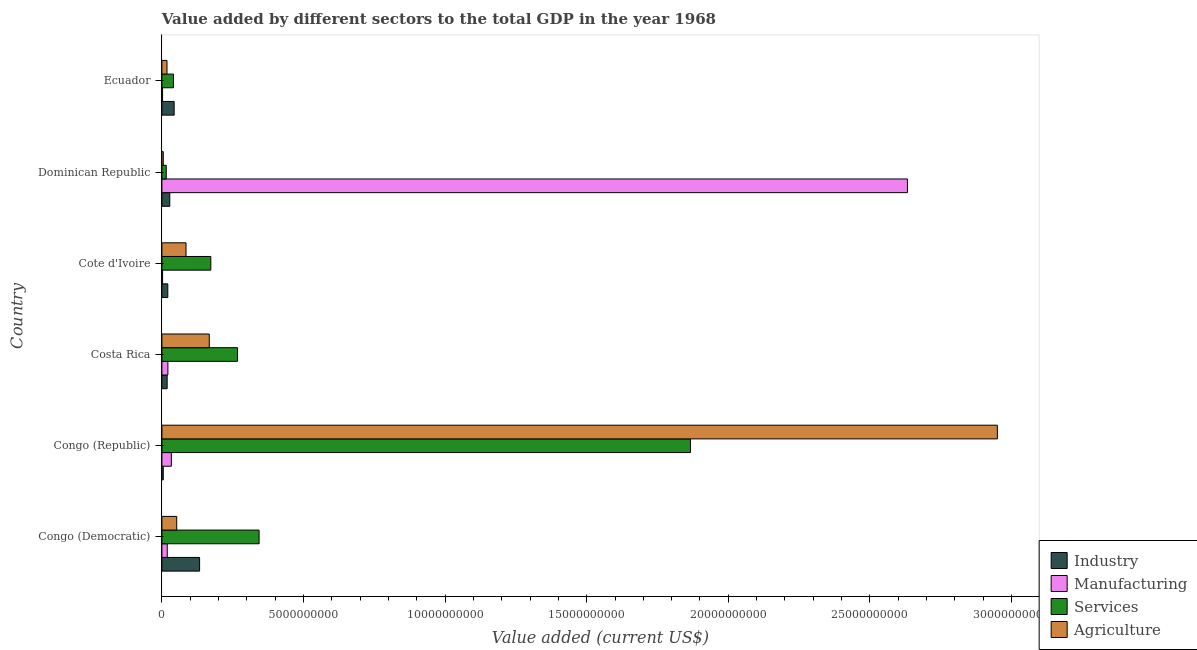How many groups of bars are there?
Ensure brevity in your answer.  6. How many bars are there on the 2nd tick from the bottom?
Ensure brevity in your answer.  4. What is the label of the 1st group of bars from the top?
Provide a succinct answer. Ecuador. In how many cases, is the number of bars for a given country not equal to the number of legend labels?
Ensure brevity in your answer.  0. What is the value added by industrial sector in Ecuador?
Offer a very short reply. 4.33e+08. Across all countries, what is the maximum value added by agricultural sector?
Your response must be concise. 2.95e+1. Across all countries, what is the minimum value added by manufacturing sector?
Your response must be concise. 2.34e+07. In which country was the value added by services sector maximum?
Keep it short and to the point. Congo (Republic). In which country was the value added by industrial sector minimum?
Keep it short and to the point. Congo (Republic). What is the total value added by services sector in the graph?
Your response must be concise. 2.71e+1. What is the difference between the value added by manufacturing sector in Congo (Democratic) and that in Congo (Republic)?
Make the answer very short. -1.45e+08. What is the difference between the value added by services sector in Ecuador and the value added by agricultural sector in Congo (Democratic)?
Offer a very short reply. -1.15e+08. What is the average value added by services sector per country?
Offer a terse response. 4.51e+09. What is the difference between the value added by services sector and value added by manufacturing sector in Cote d'Ivoire?
Ensure brevity in your answer.  1.70e+09. In how many countries, is the value added by industrial sector greater than 8000000000 US$?
Provide a succinct answer. 0. What is the ratio of the value added by services sector in Congo (Republic) to that in Ecuador?
Offer a very short reply. 45.74. Is the value added by industrial sector in Congo (Democratic) less than that in Costa Rica?
Provide a succinct answer. No. Is the difference between the value added by industrial sector in Congo (Democratic) and Cote d'Ivoire greater than the difference between the value added by agricultural sector in Congo (Democratic) and Cote d'Ivoire?
Ensure brevity in your answer.  Yes. What is the difference between the highest and the second highest value added by agricultural sector?
Ensure brevity in your answer.  2.78e+1. What is the difference between the highest and the lowest value added by services sector?
Keep it short and to the point. 1.85e+1. What does the 3rd bar from the top in Costa Rica represents?
Keep it short and to the point. Manufacturing. What does the 3rd bar from the bottom in Cote d'Ivoire represents?
Ensure brevity in your answer.  Services. Are all the bars in the graph horizontal?
Keep it short and to the point. Yes. How many countries are there in the graph?
Offer a terse response. 6. Are the values on the major ticks of X-axis written in scientific E-notation?
Ensure brevity in your answer.  No. Does the graph contain any zero values?
Offer a very short reply. No. Does the graph contain grids?
Your answer should be compact. No. Where does the legend appear in the graph?
Provide a succinct answer. Bottom right. How many legend labels are there?
Your response must be concise. 4. What is the title of the graph?
Make the answer very short. Value added by different sectors to the total GDP in the year 1968. Does "CO2 damage" appear as one of the legend labels in the graph?
Ensure brevity in your answer.  No. What is the label or title of the X-axis?
Provide a succinct answer. Value added (current US$). What is the Value added (current US$) in Industry in Congo (Democratic)?
Offer a very short reply. 1.33e+09. What is the Value added (current US$) of Manufacturing in Congo (Democratic)?
Provide a short and direct response. 1.89e+08. What is the Value added (current US$) of Services in Congo (Democratic)?
Make the answer very short. 3.43e+09. What is the Value added (current US$) in Agriculture in Congo (Democratic)?
Ensure brevity in your answer.  5.24e+08. What is the Value added (current US$) in Industry in Congo (Republic)?
Provide a succinct answer. 4.85e+07. What is the Value added (current US$) in Manufacturing in Congo (Republic)?
Your answer should be very brief. 3.34e+08. What is the Value added (current US$) of Services in Congo (Republic)?
Your answer should be compact. 1.87e+1. What is the Value added (current US$) in Agriculture in Congo (Republic)?
Your answer should be very brief. 2.95e+1. What is the Value added (current US$) of Industry in Costa Rica?
Ensure brevity in your answer.  1.86e+08. What is the Value added (current US$) in Manufacturing in Costa Rica?
Your answer should be compact. 2.11e+08. What is the Value added (current US$) of Services in Costa Rica?
Your answer should be compact. 2.67e+09. What is the Value added (current US$) of Agriculture in Costa Rica?
Make the answer very short. 1.67e+09. What is the Value added (current US$) of Industry in Cote d'Ivoire?
Make the answer very short. 2.09e+08. What is the Value added (current US$) of Manufacturing in Cote d'Ivoire?
Ensure brevity in your answer.  2.43e+07. What is the Value added (current US$) of Services in Cote d'Ivoire?
Provide a succinct answer. 1.73e+09. What is the Value added (current US$) in Agriculture in Cote d'Ivoire?
Offer a terse response. 8.52e+08. What is the Value added (current US$) of Industry in Dominican Republic?
Offer a terse response. 2.78e+08. What is the Value added (current US$) in Manufacturing in Dominican Republic?
Keep it short and to the point. 2.63e+1. What is the Value added (current US$) of Services in Dominican Republic?
Your answer should be compact. 1.53e+08. What is the Value added (current US$) in Agriculture in Dominican Republic?
Offer a terse response. 4.93e+07. What is the Value added (current US$) in Industry in Ecuador?
Keep it short and to the point. 4.33e+08. What is the Value added (current US$) of Manufacturing in Ecuador?
Your answer should be compact. 2.34e+07. What is the Value added (current US$) in Services in Ecuador?
Provide a short and direct response. 4.08e+08. What is the Value added (current US$) in Agriculture in Ecuador?
Give a very brief answer. 1.80e+08. Across all countries, what is the maximum Value added (current US$) of Industry?
Provide a succinct answer. 1.33e+09. Across all countries, what is the maximum Value added (current US$) in Manufacturing?
Provide a succinct answer. 2.63e+1. Across all countries, what is the maximum Value added (current US$) of Services?
Your response must be concise. 1.87e+1. Across all countries, what is the maximum Value added (current US$) of Agriculture?
Your response must be concise. 2.95e+1. Across all countries, what is the minimum Value added (current US$) of Industry?
Offer a very short reply. 4.85e+07. Across all countries, what is the minimum Value added (current US$) of Manufacturing?
Offer a terse response. 2.34e+07. Across all countries, what is the minimum Value added (current US$) in Services?
Your response must be concise. 1.53e+08. Across all countries, what is the minimum Value added (current US$) in Agriculture?
Give a very brief answer. 4.93e+07. What is the total Value added (current US$) of Industry in the graph?
Your answer should be very brief. 2.48e+09. What is the total Value added (current US$) of Manufacturing in the graph?
Your response must be concise. 2.71e+1. What is the total Value added (current US$) in Services in the graph?
Offer a terse response. 2.71e+1. What is the total Value added (current US$) in Agriculture in the graph?
Your answer should be very brief. 3.28e+1. What is the difference between the Value added (current US$) in Industry in Congo (Democratic) and that in Congo (Republic)?
Your answer should be compact. 1.28e+09. What is the difference between the Value added (current US$) in Manufacturing in Congo (Democratic) and that in Congo (Republic)?
Offer a very short reply. -1.45e+08. What is the difference between the Value added (current US$) of Services in Congo (Democratic) and that in Congo (Republic)?
Provide a succinct answer. -1.52e+1. What is the difference between the Value added (current US$) in Agriculture in Congo (Democratic) and that in Congo (Republic)?
Provide a succinct answer. -2.90e+1. What is the difference between the Value added (current US$) of Industry in Congo (Democratic) and that in Costa Rica?
Your answer should be very brief. 1.15e+09. What is the difference between the Value added (current US$) of Manufacturing in Congo (Democratic) and that in Costa Rica?
Your answer should be compact. -2.24e+07. What is the difference between the Value added (current US$) of Services in Congo (Democratic) and that in Costa Rica?
Your answer should be compact. 7.61e+08. What is the difference between the Value added (current US$) in Agriculture in Congo (Democratic) and that in Costa Rica?
Ensure brevity in your answer.  -1.15e+09. What is the difference between the Value added (current US$) in Industry in Congo (Democratic) and that in Cote d'Ivoire?
Give a very brief answer. 1.12e+09. What is the difference between the Value added (current US$) of Manufacturing in Congo (Democratic) and that in Cote d'Ivoire?
Make the answer very short. 1.65e+08. What is the difference between the Value added (current US$) of Services in Congo (Democratic) and that in Cote d'Ivoire?
Provide a succinct answer. 1.70e+09. What is the difference between the Value added (current US$) of Agriculture in Congo (Democratic) and that in Cote d'Ivoire?
Offer a terse response. -3.28e+08. What is the difference between the Value added (current US$) of Industry in Congo (Democratic) and that in Dominican Republic?
Your answer should be very brief. 1.05e+09. What is the difference between the Value added (current US$) in Manufacturing in Congo (Democratic) and that in Dominican Republic?
Offer a very short reply. -2.61e+1. What is the difference between the Value added (current US$) of Services in Congo (Democratic) and that in Dominican Republic?
Provide a succinct answer. 3.28e+09. What is the difference between the Value added (current US$) of Agriculture in Congo (Democratic) and that in Dominican Republic?
Provide a short and direct response. 4.74e+08. What is the difference between the Value added (current US$) in Industry in Congo (Democratic) and that in Ecuador?
Provide a short and direct response. 8.98e+08. What is the difference between the Value added (current US$) of Manufacturing in Congo (Democratic) and that in Ecuador?
Make the answer very short. 1.66e+08. What is the difference between the Value added (current US$) of Services in Congo (Democratic) and that in Ecuador?
Your answer should be very brief. 3.02e+09. What is the difference between the Value added (current US$) of Agriculture in Congo (Democratic) and that in Ecuador?
Offer a terse response. 3.43e+08. What is the difference between the Value added (current US$) of Industry in Congo (Republic) and that in Costa Rica?
Offer a terse response. -1.37e+08. What is the difference between the Value added (current US$) of Manufacturing in Congo (Republic) and that in Costa Rica?
Make the answer very short. 1.22e+08. What is the difference between the Value added (current US$) of Services in Congo (Republic) and that in Costa Rica?
Your answer should be very brief. 1.60e+1. What is the difference between the Value added (current US$) of Agriculture in Congo (Republic) and that in Costa Rica?
Your answer should be compact. 2.78e+1. What is the difference between the Value added (current US$) in Industry in Congo (Republic) and that in Cote d'Ivoire?
Provide a short and direct response. -1.60e+08. What is the difference between the Value added (current US$) of Manufacturing in Congo (Republic) and that in Cote d'Ivoire?
Your answer should be compact. 3.09e+08. What is the difference between the Value added (current US$) of Services in Congo (Republic) and that in Cote d'Ivoire?
Provide a short and direct response. 1.69e+1. What is the difference between the Value added (current US$) of Agriculture in Congo (Republic) and that in Cote d'Ivoire?
Give a very brief answer. 2.87e+1. What is the difference between the Value added (current US$) in Industry in Congo (Republic) and that in Dominican Republic?
Keep it short and to the point. -2.30e+08. What is the difference between the Value added (current US$) of Manufacturing in Congo (Republic) and that in Dominican Republic?
Provide a short and direct response. -2.60e+1. What is the difference between the Value added (current US$) of Services in Congo (Republic) and that in Dominican Republic?
Offer a very short reply. 1.85e+1. What is the difference between the Value added (current US$) of Agriculture in Congo (Republic) and that in Dominican Republic?
Offer a very short reply. 2.95e+1. What is the difference between the Value added (current US$) of Industry in Congo (Republic) and that in Ecuador?
Offer a very short reply. -3.84e+08. What is the difference between the Value added (current US$) of Manufacturing in Congo (Republic) and that in Ecuador?
Your response must be concise. 3.10e+08. What is the difference between the Value added (current US$) in Services in Congo (Republic) and that in Ecuador?
Provide a succinct answer. 1.83e+1. What is the difference between the Value added (current US$) in Agriculture in Congo (Republic) and that in Ecuador?
Offer a very short reply. 2.93e+1. What is the difference between the Value added (current US$) in Industry in Costa Rica and that in Cote d'Ivoire?
Offer a very short reply. -2.32e+07. What is the difference between the Value added (current US$) in Manufacturing in Costa Rica and that in Cote d'Ivoire?
Ensure brevity in your answer.  1.87e+08. What is the difference between the Value added (current US$) of Services in Costa Rica and that in Cote d'Ivoire?
Your response must be concise. 9.44e+08. What is the difference between the Value added (current US$) of Agriculture in Costa Rica and that in Cote d'Ivoire?
Offer a terse response. 8.21e+08. What is the difference between the Value added (current US$) of Industry in Costa Rica and that in Dominican Republic?
Make the answer very short. -9.24e+07. What is the difference between the Value added (current US$) in Manufacturing in Costa Rica and that in Dominican Republic?
Provide a succinct answer. -2.61e+1. What is the difference between the Value added (current US$) in Services in Costa Rica and that in Dominican Republic?
Provide a succinct answer. 2.52e+09. What is the difference between the Value added (current US$) in Agriculture in Costa Rica and that in Dominican Republic?
Give a very brief answer. 1.62e+09. What is the difference between the Value added (current US$) of Industry in Costa Rica and that in Ecuador?
Ensure brevity in your answer.  -2.47e+08. What is the difference between the Value added (current US$) of Manufacturing in Costa Rica and that in Ecuador?
Offer a very short reply. 1.88e+08. What is the difference between the Value added (current US$) of Services in Costa Rica and that in Ecuador?
Your answer should be very brief. 2.26e+09. What is the difference between the Value added (current US$) of Agriculture in Costa Rica and that in Ecuador?
Keep it short and to the point. 1.49e+09. What is the difference between the Value added (current US$) in Industry in Cote d'Ivoire and that in Dominican Republic?
Keep it short and to the point. -6.92e+07. What is the difference between the Value added (current US$) in Manufacturing in Cote d'Ivoire and that in Dominican Republic?
Offer a very short reply. -2.63e+1. What is the difference between the Value added (current US$) of Services in Cote d'Ivoire and that in Dominican Republic?
Ensure brevity in your answer.  1.57e+09. What is the difference between the Value added (current US$) of Agriculture in Cote d'Ivoire and that in Dominican Republic?
Offer a very short reply. 8.02e+08. What is the difference between the Value added (current US$) of Industry in Cote d'Ivoire and that in Ecuador?
Keep it short and to the point. -2.24e+08. What is the difference between the Value added (current US$) of Manufacturing in Cote d'Ivoire and that in Ecuador?
Offer a terse response. 8.48e+05. What is the difference between the Value added (current US$) of Services in Cote d'Ivoire and that in Ecuador?
Keep it short and to the point. 1.32e+09. What is the difference between the Value added (current US$) of Agriculture in Cote d'Ivoire and that in Ecuador?
Offer a very short reply. 6.71e+08. What is the difference between the Value added (current US$) in Industry in Dominican Republic and that in Ecuador?
Your answer should be compact. -1.55e+08. What is the difference between the Value added (current US$) in Manufacturing in Dominican Republic and that in Ecuador?
Your response must be concise. 2.63e+1. What is the difference between the Value added (current US$) in Services in Dominican Republic and that in Ecuador?
Offer a terse response. -2.55e+08. What is the difference between the Value added (current US$) in Agriculture in Dominican Republic and that in Ecuador?
Offer a very short reply. -1.31e+08. What is the difference between the Value added (current US$) in Industry in Congo (Democratic) and the Value added (current US$) in Manufacturing in Congo (Republic)?
Keep it short and to the point. 9.97e+08. What is the difference between the Value added (current US$) of Industry in Congo (Democratic) and the Value added (current US$) of Services in Congo (Republic)?
Your answer should be compact. -1.73e+1. What is the difference between the Value added (current US$) in Industry in Congo (Democratic) and the Value added (current US$) in Agriculture in Congo (Republic)?
Your response must be concise. -2.82e+1. What is the difference between the Value added (current US$) in Manufacturing in Congo (Democratic) and the Value added (current US$) in Services in Congo (Republic)?
Make the answer very short. -1.85e+1. What is the difference between the Value added (current US$) in Manufacturing in Congo (Democratic) and the Value added (current US$) in Agriculture in Congo (Republic)?
Your answer should be very brief. -2.93e+1. What is the difference between the Value added (current US$) of Services in Congo (Democratic) and the Value added (current US$) of Agriculture in Congo (Republic)?
Your answer should be compact. -2.61e+1. What is the difference between the Value added (current US$) in Industry in Congo (Democratic) and the Value added (current US$) in Manufacturing in Costa Rica?
Make the answer very short. 1.12e+09. What is the difference between the Value added (current US$) of Industry in Congo (Democratic) and the Value added (current US$) of Services in Costa Rica?
Offer a terse response. -1.34e+09. What is the difference between the Value added (current US$) of Industry in Congo (Democratic) and the Value added (current US$) of Agriculture in Costa Rica?
Offer a terse response. -3.42e+08. What is the difference between the Value added (current US$) in Manufacturing in Congo (Democratic) and the Value added (current US$) in Services in Costa Rica?
Your answer should be very brief. -2.48e+09. What is the difference between the Value added (current US$) of Manufacturing in Congo (Democratic) and the Value added (current US$) of Agriculture in Costa Rica?
Give a very brief answer. -1.48e+09. What is the difference between the Value added (current US$) in Services in Congo (Democratic) and the Value added (current US$) in Agriculture in Costa Rica?
Provide a short and direct response. 1.76e+09. What is the difference between the Value added (current US$) of Industry in Congo (Democratic) and the Value added (current US$) of Manufacturing in Cote d'Ivoire?
Keep it short and to the point. 1.31e+09. What is the difference between the Value added (current US$) of Industry in Congo (Democratic) and the Value added (current US$) of Services in Cote d'Ivoire?
Offer a terse response. -3.96e+08. What is the difference between the Value added (current US$) in Industry in Congo (Democratic) and the Value added (current US$) in Agriculture in Cote d'Ivoire?
Keep it short and to the point. 4.79e+08. What is the difference between the Value added (current US$) in Manufacturing in Congo (Democratic) and the Value added (current US$) in Services in Cote d'Ivoire?
Your answer should be compact. -1.54e+09. What is the difference between the Value added (current US$) of Manufacturing in Congo (Democratic) and the Value added (current US$) of Agriculture in Cote d'Ivoire?
Offer a very short reply. -6.63e+08. What is the difference between the Value added (current US$) in Services in Congo (Democratic) and the Value added (current US$) in Agriculture in Cote d'Ivoire?
Make the answer very short. 2.58e+09. What is the difference between the Value added (current US$) of Industry in Congo (Democratic) and the Value added (current US$) of Manufacturing in Dominican Republic?
Provide a short and direct response. -2.50e+1. What is the difference between the Value added (current US$) of Industry in Congo (Democratic) and the Value added (current US$) of Services in Dominican Republic?
Offer a very short reply. 1.18e+09. What is the difference between the Value added (current US$) of Industry in Congo (Democratic) and the Value added (current US$) of Agriculture in Dominican Republic?
Ensure brevity in your answer.  1.28e+09. What is the difference between the Value added (current US$) of Manufacturing in Congo (Democratic) and the Value added (current US$) of Services in Dominican Republic?
Your response must be concise. 3.55e+07. What is the difference between the Value added (current US$) in Manufacturing in Congo (Democratic) and the Value added (current US$) in Agriculture in Dominican Republic?
Give a very brief answer. 1.40e+08. What is the difference between the Value added (current US$) of Services in Congo (Democratic) and the Value added (current US$) of Agriculture in Dominican Republic?
Provide a short and direct response. 3.38e+09. What is the difference between the Value added (current US$) in Industry in Congo (Democratic) and the Value added (current US$) in Manufacturing in Ecuador?
Keep it short and to the point. 1.31e+09. What is the difference between the Value added (current US$) of Industry in Congo (Democratic) and the Value added (current US$) of Services in Ecuador?
Provide a succinct answer. 9.23e+08. What is the difference between the Value added (current US$) of Industry in Congo (Democratic) and the Value added (current US$) of Agriculture in Ecuador?
Give a very brief answer. 1.15e+09. What is the difference between the Value added (current US$) in Manufacturing in Congo (Democratic) and the Value added (current US$) in Services in Ecuador?
Your response must be concise. -2.19e+08. What is the difference between the Value added (current US$) of Manufacturing in Congo (Democratic) and the Value added (current US$) of Agriculture in Ecuador?
Offer a very short reply. 8.86e+06. What is the difference between the Value added (current US$) of Services in Congo (Democratic) and the Value added (current US$) of Agriculture in Ecuador?
Provide a succinct answer. 3.25e+09. What is the difference between the Value added (current US$) in Industry in Congo (Republic) and the Value added (current US$) in Manufacturing in Costa Rica?
Make the answer very short. -1.63e+08. What is the difference between the Value added (current US$) of Industry in Congo (Republic) and the Value added (current US$) of Services in Costa Rica?
Provide a succinct answer. -2.62e+09. What is the difference between the Value added (current US$) of Industry in Congo (Republic) and the Value added (current US$) of Agriculture in Costa Rica?
Make the answer very short. -1.62e+09. What is the difference between the Value added (current US$) of Manufacturing in Congo (Republic) and the Value added (current US$) of Services in Costa Rica?
Your response must be concise. -2.34e+09. What is the difference between the Value added (current US$) in Manufacturing in Congo (Republic) and the Value added (current US$) in Agriculture in Costa Rica?
Ensure brevity in your answer.  -1.34e+09. What is the difference between the Value added (current US$) of Services in Congo (Republic) and the Value added (current US$) of Agriculture in Costa Rica?
Provide a short and direct response. 1.70e+1. What is the difference between the Value added (current US$) of Industry in Congo (Republic) and the Value added (current US$) of Manufacturing in Cote d'Ivoire?
Provide a succinct answer. 2.42e+07. What is the difference between the Value added (current US$) in Industry in Congo (Republic) and the Value added (current US$) in Services in Cote d'Ivoire?
Your response must be concise. -1.68e+09. What is the difference between the Value added (current US$) in Industry in Congo (Republic) and the Value added (current US$) in Agriculture in Cote d'Ivoire?
Give a very brief answer. -8.03e+08. What is the difference between the Value added (current US$) in Manufacturing in Congo (Republic) and the Value added (current US$) in Services in Cote d'Ivoire?
Offer a very short reply. -1.39e+09. What is the difference between the Value added (current US$) in Manufacturing in Congo (Republic) and the Value added (current US$) in Agriculture in Cote d'Ivoire?
Your response must be concise. -5.18e+08. What is the difference between the Value added (current US$) in Services in Congo (Republic) and the Value added (current US$) in Agriculture in Cote d'Ivoire?
Your answer should be compact. 1.78e+1. What is the difference between the Value added (current US$) of Industry in Congo (Republic) and the Value added (current US$) of Manufacturing in Dominican Republic?
Your response must be concise. -2.63e+1. What is the difference between the Value added (current US$) in Industry in Congo (Republic) and the Value added (current US$) in Services in Dominican Republic?
Ensure brevity in your answer.  -1.05e+08. What is the difference between the Value added (current US$) in Industry in Congo (Republic) and the Value added (current US$) in Agriculture in Dominican Republic?
Make the answer very short. -8.08e+05. What is the difference between the Value added (current US$) of Manufacturing in Congo (Republic) and the Value added (current US$) of Services in Dominican Republic?
Provide a succinct answer. 1.80e+08. What is the difference between the Value added (current US$) of Manufacturing in Congo (Republic) and the Value added (current US$) of Agriculture in Dominican Republic?
Your answer should be very brief. 2.84e+08. What is the difference between the Value added (current US$) in Services in Congo (Republic) and the Value added (current US$) in Agriculture in Dominican Republic?
Keep it short and to the point. 1.86e+1. What is the difference between the Value added (current US$) in Industry in Congo (Republic) and the Value added (current US$) in Manufacturing in Ecuador?
Ensure brevity in your answer.  2.50e+07. What is the difference between the Value added (current US$) of Industry in Congo (Republic) and the Value added (current US$) of Services in Ecuador?
Give a very brief answer. -3.60e+08. What is the difference between the Value added (current US$) of Industry in Congo (Republic) and the Value added (current US$) of Agriculture in Ecuador?
Your answer should be compact. -1.32e+08. What is the difference between the Value added (current US$) of Manufacturing in Congo (Republic) and the Value added (current US$) of Services in Ecuador?
Provide a short and direct response. -7.45e+07. What is the difference between the Value added (current US$) of Manufacturing in Congo (Republic) and the Value added (current US$) of Agriculture in Ecuador?
Your answer should be compact. 1.53e+08. What is the difference between the Value added (current US$) in Services in Congo (Republic) and the Value added (current US$) in Agriculture in Ecuador?
Provide a short and direct response. 1.85e+1. What is the difference between the Value added (current US$) of Industry in Costa Rica and the Value added (current US$) of Manufacturing in Cote d'Ivoire?
Ensure brevity in your answer.  1.61e+08. What is the difference between the Value added (current US$) in Industry in Costa Rica and the Value added (current US$) in Services in Cote d'Ivoire?
Provide a succinct answer. -1.54e+09. What is the difference between the Value added (current US$) of Industry in Costa Rica and the Value added (current US$) of Agriculture in Cote d'Ivoire?
Offer a terse response. -6.66e+08. What is the difference between the Value added (current US$) of Manufacturing in Costa Rica and the Value added (current US$) of Services in Cote d'Ivoire?
Offer a terse response. -1.52e+09. What is the difference between the Value added (current US$) in Manufacturing in Costa Rica and the Value added (current US$) in Agriculture in Cote d'Ivoire?
Your answer should be compact. -6.40e+08. What is the difference between the Value added (current US$) of Services in Costa Rica and the Value added (current US$) of Agriculture in Cote d'Ivoire?
Provide a short and direct response. 1.82e+09. What is the difference between the Value added (current US$) in Industry in Costa Rica and the Value added (current US$) in Manufacturing in Dominican Republic?
Provide a succinct answer. -2.61e+1. What is the difference between the Value added (current US$) of Industry in Costa Rica and the Value added (current US$) of Services in Dominican Republic?
Your response must be concise. 3.21e+07. What is the difference between the Value added (current US$) of Industry in Costa Rica and the Value added (current US$) of Agriculture in Dominican Republic?
Your answer should be compact. 1.36e+08. What is the difference between the Value added (current US$) in Manufacturing in Costa Rica and the Value added (current US$) in Services in Dominican Republic?
Keep it short and to the point. 5.79e+07. What is the difference between the Value added (current US$) of Manufacturing in Costa Rica and the Value added (current US$) of Agriculture in Dominican Republic?
Provide a succinct answer. 1.62e+08. What is the difference between the Value added (current US$) in Services in Costa Rica and the Value added (current US$) in Agriculture in Dominican Republic?
Keep it short and to the point. 2.62e+09. What is the difference between the Value added (current US$) in Industry in Costa Rica and the Value added (current US$) in Manufacturing in Ecuador?
Provide a short and direct response. 1.62e+08. What is the difference between the Value added (current US$) of Industry in Costa Rica and the Value added (current US$) of Services in Ecuador?
Give a very brief answer. -2.22e+08. What is the difference between the Value added (current US$) of Industry in Costa Rica and the Value added (current US$) of Agriculture in Ecuador?
Keep it short and to the point. 5.49e+06. What is the difference between the Value added (current US$) of Manufacturing in Costa Rica and the Value added (current US$) of Services in Ecuador?
Make the answer very short. -1.97e+08. What is the difference between the Value added (current US$) in Manufacturing in Costa Rica and the Value added (current US$) in Agriculture in Ecuador?
Provide a short and direct response. 3.13e+07. What is the difference between the Value added (current US$) in Services in Costa Rica and the Value added (current US$) in Agriculture in Ecuador?
Give a very brief answer. 2.49e+09. What is the difference between the Value added (current US$) in Industry in Cote d'Ivoire and the Value added (current US$) in Manufacturing in Dominican Republic?
Keep it short and to the point. -2.61e+1. What is the difference between the Value added (current US$) in Industry in Cote d'Ivoire and the Value added (current US$) in Services in Dominican Republic?
Provide a succinct answer. 5.53e+07. What is the difference between the Value added (current US$) of Industry in Cote d'Ivoire and the Value added (current US$) of Agriculture in Dominican Republic?
Provide a short and direct response. 1.60e+08. What is the difference between the Value added (current US$) of Manufacturing in Cote d'Ivoire and the Value added (current US$) of Services in Dominican Republic?
Make the answer very short. -1.29e+08. What is the difference between the Value added (current US$) of Manufacturing in Cote d'Ivoire and the Value added (current US$) of Agriculture in Dominican Republic?
Offer a very short reply. -2.50e+07. What is the difference between the Value added (current US$) of Services in Cote d'Ivoire and the Value added (current US$) of Agriculture in Dominican Republic?
Offer a very short reply. 1.68e+09. What is the difference between the Value added (current US$) in Industry in Cote d'Ivoire and the Value added (current US$) in Manufacturing in Ecuador?
Provide a short and direct response. 1.85e+08. What is the difference between the Value added (current US$) of Industry in Cote d'Ivoire and the Value added (current US$) of Services in Ecuador?
Keep it short and to the point. -1.99e+08. What is the difference between the Value added (current US$) in Industry in Cote d'Ivoire and the Value added (current US$) in Agriculture in Ecuador?
Ensure brevity in your answer.  2.87e+07. What is the difference between the Value added (current US$) in Manufacturing in Cote d'Ivoire and the Value added (current US$) in Services in Ecuador?
Provide a short and direct response. -3.84e+08. What is the difference between the Value added (current US$) in Manufacturing in Cote d'Ivoire and the Value added (current US$) in Agriculture in Ecuador?
Your answer should be very brief. -1.56e+08. What is the difference between the Value added (current US$) in Services in Cote d'Ivoire and the Value added (current US$) in Agriculture in Ecuador?
Provide a succinct answer. 1.55e+09. What is the difference between the Value added (current US$) in Industry in Dominican Republic and the Value added (current US$) in Manufacturing in Ecuador?
Your response must be concise. 2.55e+08. What is the difference between the Value added (current US$) in Industry in Dominican Republic and the Value added (current US$) in Services in Ecuador?
Offer a terse response. -1.30e+08. What is the difference between the Value added (current US$) of Industry in Dominican Republic and the Value added (current US$) of Agriculture in Ecuador?
Provide a short and direct response. 9.79e+07. What is the difference between the Value added (current US$) in Manufacturing in Dominican Republic and the Value added (current US$) in Services in Ecuador?
Make the answer very short. 2.59e+1. What is the difference between the Value added (current US$) in Manufacturing in Dominican Republic and the Value added (current US$) in Agriculture in Ecuador?
Your answer should be compact. 2.61e+1. What is the difference between the Value added (current US$) in Services in Dominican Republic and the Value added (current US$) in Agriculture in Ecuador?
Ensure brevity in your answer.  -2.66e+07. What is the average Value added (current US$) in Industry per country?
Your answer should be very brief. 4.14e+08. What is the average Value added (current US$) in Manufacturing per country?
Offer a terse response. 4.52e+09. What is the average Value added (current US$) of Services per country?
Keep it short and to the point. 4.51e+09. What is the average Value added (current US$) of Agriculture per country?
Keep it short and to the point. 5.46e+09. What is the difference between the Value added (current US$) of Industry and Value added (current US$) of Manufacturing in Congo (Democratic)?
Ensure brevity in your answer.  1.14e+09. What is the difference between the Value added (current US$) of Industry and Value added (current US$) of Services in Congo (Democratic)?
Provide a succinct answer. -2.10e+09. What is the difference between the Value added (current US$) of Industry and Value added (current US$) of Agriculture in Congo (Democratic)?
Provide a short and direct response. 8.07e+08. What is the difference between the Value added (current US$) of Manufacturing and Value added (current US$) of Services in Congo (Democratic)?
Keep it short and to the point. -3.24e+09. What is the difference between the Value added (current US$) in Manufacturing and Value added (current US$) in Agriculture in Congo (Democratic)?
Your response must be concise. -3.35e+08. What is the difference between the Value added (current US$) in Services and Value added (current US$) in Agriculture in Congo (Democratic)?
Keep it short and to the point. 2.91e+09. What is the difference between the Value added (current US$) of Industry and Value added (current US$) of Manufacturing in Congo (Republic)?
Provide a short and direct response. -2.85e+08. What is the difference between the Value added (current US$) of Industry and Value added (current US$) of Services in Congo (Republic)?
Make the answer very short. -1.86e+1. What is the difference between the Value added (current US$) of Industry and Value added (current US$) of Agriculture in Congo (Republic)?
Your answer should be very brief. -2.95e+1. What is the difference between the Value added (current US$) in Manufacturing and Value added (current US$) in Services in Congo (Republic)?
Provide a short and direct response. -1.83e+1. What is the difference between the Value added (current US$) in Manufacturing and Value added (current US$) in Agriculture in Congo (Republic)?
Keep it short and to the point. -2.92e+1. What is the difference between the Value added (current US$) in Services and Value added (current US$) in Agriculture in Congo (Republic)?
Keep it short and to the point. -1.08e+1. What is the difference between the Value added (current US$) of Industry and Value added (current US$) of Manufacturing in Costa Rica?
Provide a short and direct response. -2.58e+07. What is the difference between the Value added (current US$) in Industry and Value added (current US$) in Services in Costa Rica?
Your answer should be very brief. -2.49e+09. What is the difference between the Value added (current US$) in Industry and Value added (current US$) in Agriculture in Costa Rica?
Keep it short and to the point. -1.49e+09. What is the difference between the Value added (current US$) in Manufacturing and Value added (current US$) in Services in Costa Rica?
Make the answer very short. -2.46e+09. What is the difference between the Value added (current US$) of Manufacturing and Value added (current US$) of Agriculture in Costa Rica?
Your response must be concise. -1.46e+09. What is the difference between the Value added (current US$) in Services and Value added (current US$) in Agriculture in Costa Rica?
Your answer should be compact. 9.99e+08. What is the difference between the Value added (current US$) in Industry and Value added (current US$) in Manufacturing in Cote d'Ivoire?
Offer a terse response. 1.85e+08. What is the difference between the Value added (current US$) of Industry and Value added (current US$) of Services in Cote d'Ivoire?
Make the answer very short. -1.52e+09. What is the difference between the Value added (current US$) in Industry and Value added (current US$) in Agriculture in Cote d'Ivoire?
Your answer should be compact. -6.43e+08. What is the difference between the Value added (current US$) in Manufacturing and Value added (current US$) in Services in Cote d'Ivoire?
Make the answer very short. -1.70e+09. What is the difference between the Value added (current US$) of Manufacturing and Value added (current US$) of Agriculture in Cote d'Ivoire?
Provide a succinct answer. -8.27e+08. What is the difference between the Value added (current US$) of Services and Value added (current US$) of Agriculture in Cote d'Ivoire?
Your response must be concise. 8.76e+08. What is the difference between the Value added (current US$) of Industry and Value added (current US$) of Manufacturing in Dominican Republic?
Provide a short and direct response. -2.60e+1. What is the difference between the Value added (current US$) of Industry and Value added (current US$) of Services in Dominican Republic?
Keep it short and to the point. 1.25e+08. What is the difference between the Value added (current US$) in Industry and Value added (current US$) in Agriculture in Dominican Republic?
Offer a terse response. 2.29e+08. What is the difference between the Value added (current US$) of Manufacturing and Value added (current US$) of Services in Dominican Republic?
Make the answer very short. 2.62e+1. What is the difference between the Value added (current US$) of Manufacturing and Value added (current US$) of Agriculture in Dominican Republic?
Your response must be concise. 2.63e+1. What is the difference between the Value added (current US$) in Services and Value added (current US$) in Agriculture in Dominican Republic?
Keep it short and to the point. 1.04e+08. What is the difference between the Value added (current US$) in Industry and Value added (current US$) in Manufacturing in Ecuador?
Your answer should be compact. 4.09e+08. What is the difference between the Value added (current US$) of Industry and Value added (current US$) of Services in Ecuador?
Your response must be concise. 2.45e+07. What is the difference between the Value added (current US$) of Industry and Value added (current US$) of Agriculture in Ecuador?
Your answer should be very brief. 2.52e+08. What is the difference between the Value added (current US$) of Manufacturing and Value added (current US$) of Services in Ecuador?
Ensure brevity in your answer.  -3.85e+08. What is the difference between the Value added (current US$) in Manufacturing and Value added (current US$) in Agriculture in Ecuador?
Keep it short and to the point. -1.57e+08. What is the difference between the Value added (current US$) in Services and Value added (current US$) in Agriculture in Ecuador?
Keep it short and to the point. 2.28e+08. What is the ratio of the Value added (current US$) of Industry in Congo (Democratic) to that in Congo (Republic)?
Offer a terse response. 27.46. What is the ratio of the Value added (current US$) in Manufacturing in Congo (Democratic) to that in Congo (Republic)?
Provide a short and direct response. 0.57. What is the ratio of the Value added (current US$) of Services in Congo (Democratic) to that in Congo (Republic)?
Provide a succinct answer. 0.18. What is the ratio of the Value added (current US$) of Agriculture in Congo (Democratic) to that in Congo (Republic)?
Your response must be concise. 0.02. What is the ratio of the Value added (current US$) in Industry in Congo (Democratic) to that in Costa Rica?
Keep it short and to the point. 7.17. What is the ratio of the Value added (current US$) of Manufacturing in Congo (Democratic) to that in Costa Rica?
Your answer should be very brief. 0.89. What is the ratio of the Value added (current US$) of Services in Congo (Democratic) to that in Costa Rica?
Provide a succinct answer. 1.28. What is the ratio of the Value added (current US$) of Agriculture in Congo (Democratic) to that in Costa Rica?
Give a very brief answer. 0.31. What is the ratio of the Value added (current US$) of Industry in Congo (Democratic) to that in Cote d'Ivoire?
Ensure brevity in your answer.  6.37. What is the ratio of the Value added (current US$) in Manufacturing in Congo (Democratic) to that in Cote d'Ivoire?
Keep it short and to the point. 7.79. What is the ratio of the Value added (current US$) in Services in Congo (Democratic) to that in Cote d'Ivoire?
Your response must be concise. 1.99. What is the ratio of the Value added (current US$) of Agriculture in Congo (Democratic) to that in Cote d'Ivoire?
Provide a short and direct response. 0.61. What is the ratio of the Value added (current US$) in Industry in Congo (Democratic) to that in Dominican Republic?
Provide a succinct answer. 4.79. What is the ratio of the Value added (current US$) in Manufacturing in Congo (Democratic) to that in Dominican Republic?
Give a very brief answer. 0.01. What is the ratio of the Value added (current US$) in Services in Congo (Democratic) to that in Dominican Republic?
Provide a short and direct response. 22.36. What is the ratio of the Value added (current US$) of Agriculture in Congo (Democratic) to that in Dominican Republic?
Offer a very short reply. 10.62. What is the ratio of the Value added (current US$) in Industry in Congo (Democratic) to that in Ecuador?
Ensure brevity in your answer.  3.08. What is the ratio of the Value added (current US$) in Manufacturing in Congo (Democratic) to that in Ecuador?
Your response must be concise. 8.07. What is the ratio of the Value added (current US$) in Services in Congo (Democratic) to that in Ecuador?
Keep it short and to the point. 8.41. What is the ratio of the Value added (current US$) of Agriculture in Congo (Democratic) to that in Ecuador?
Your response must be concise. 2.91. What is the ratio of the Value added (current US$) of Industry in Congo (Republic) to that in Costa Rica?
Provide a short and direct response. 0.26. What is the ratio of the Value added (current US$) in Manufacturing in Congo (Republic) to that in Costa Rica?
Make the answer very short. 1.58. What is the ratio of the Value added (current US$) in Services in Congo (Republic) to that in Costa Rica?
Your answer should be compact. 6.99. What is the ratio of the Value added (current US$) in Agriculture in Congo (Republic) to that in Costa Rica?
Your response must be concise. 17.64. What is the ratio of the Value added (current US$) in Industry in Congo (Republic) to that in Cote d'Ivoire?
Your response must be concise. 0.23. What is the ratio of the Value added (current US$) of Manufacturing in Congo (Republic) to that in Cote d'Ivoire?
Ensure brevity in your answer.  13.74. What is the ratio of the Value added (current US$) in Services in Congo (Republic) to that in Cote d'Ivoire?
Provide a short and direct response. 10.81. What is the ratio of the Value added (current US$) of Agriculture in Congo (Republic) to that in Cote d'Ivoire?
Give a very brief answer. 34.64. What is the ratio of the Value added (current US$) of Industry in Congo (Republic) to that in Dominican Republic?
Offer a very short reply. 0.17. What is the ratio of the Value added (current US$) in Manufacturing in Congo (Republic) to that in Dominican Republic?
Provide a succinct answer. 0.01. What is the ratio of the Value added (current US$) of Services in Congo (Republic) to that in Dominican Republic?
Your answer should be very brief. 121.6. What is the ratio of the Value added (current US$) in Agriculture in Congo (Republic) to that in Dominican Republic?
Ensure brevity in your answer.  598.68. What is the ratio of the Value added (current US$) in Industry in Congo (Republic) to that in Ecuador?
Make the answer very short. 0.11. What is the ratio of the Value added (current US$) in Manufacturing in Congo (Republic) to that in Ecuador?
Your answer should be compact. 14.24. What is the ratio of the Value added (current US$) of Services in Congo (Republic) to that in Ecuador?
Offer a terse response. 45.74. What is the ratio of the Value added (current US$) in Agriculture in Congo (Republic) to that in Ecuador?
Keep it short and to the point. 163.78. What is the ratio of the Value added (current US$) of Manufacturing in Costa Rica to that in Cote d'Ivoire?
Keep it short and to the point. 8.71. What is the ratio of the Value added (current US$) in Services in Costa Rica to that in Cote d'Ivoire?
Offer a terse response. 1.55. What is the ratio of the Value added (current US$) of Agriculture in Costa Rica to that in Cote d'Ivoire?
Provide a short and direct response. 1.96. What is the ratio of the Value added (current US$) in Industry in Costa Rica to that in Dominican Republic?
Provide a short and direct response. 0.67. What is the ratio of the Value added (current US$) in Manufacturing in Costa Rica to that in Dominican Republic?
Provide a succinct answer. 0.01. What is the ratio of the Value added (current US$) in Services in Costa Rica to that in Dominican Republic?
Your answer should be compact. 17.4. What is the ratio of the Value added (current US$) in Agriculture in Costa Rica to that in Dominican Republic?
Keep it short and to the point. 33.94. What is the ratio of the Value added (current US$) of Industry in Costa Rica to that in Ecuador?
Your answer should be very brief. 0.43. What is the ratio of the Value added (current US$) of Manufacturing in Costa Rica to that in Ecuador?
Ensure brevity in your answer.  9.02. What is the ratio of the Value added (current US$) in Services in Costa Rica to that in Ecuador?
Make the answer very short. 6.55. What is the ratio of the Value added (current US$) in Agriculture in Costa Rica to that in Ecuador?
Offer a terse response. 9.29. What is the ratio of the Value added (current US$) of Industry in Cote d'Ivoire to that in Dominican Republic?
Offer a very short reply. 0.75. What is the ratio of the Value added (current US$) in Manufacturing in Cote d'Ivoire to that in Dominican Republic?
Provide a succinct answer. 0. What is the ratio of the Value added (current US$) of Services in Cote d'Ivoire to that in Dominican Republic?
Your response must be concise. 11.25. What is the ratio of the Value added (current US$) of Agriculture in Cote d'Ivoire to that in Dominican Republic?
Your answer should be compact. 17.28. What is the ratio of the Value added (current US$) in Industry in Cote d'Ivoire to that in Ecuador?
Offer a very short reply. 0.48. What is the ratio of the Value added (current US$) in Manufacturing in Cote d'Ivoire to that in Ecuador?
Give a very brief answer. 1.04. What is the ratio of the Value added (current US$) in Services in Cote d'Ivoire to that in Ecuador?
Your response must be concise. 4.23. What is the ratio of the Value added (current US$) of Agriculture in Cote d'Ivoire to that in Ecuador?
Give a very brief answer. 4.73. What is the ratio of the Value added (current US$) in Industry in Dominican Republic to that in Ecuador?
Your answer should be very brief. 0.64. What is the ratio of the Value added (current US$) of Manufacturing in Dominican Republic to that in Ecuador?
Your answer should be compact. 1123.73. What is the ratio of the Value added (current US$) in Services in Dominican Republic to that in Ecuador?
Your response must be concise. 0.38. What is the ratio of the Value added (current US$) of Agriculture in Dominican Republic to that in Ecuador?
Keep it short and to the point. 0.27. What is the difference between the highest and the second highest Value added (current US$) in Industry?
Offer a terse response. 8.98e+08. What is the difference between the highest and the second highest Value added (current US$) in Manufacturing?
Give a very brief answer. 2.60e+1. What is the difference between the highest and the second highest Value added (current US$) in Services?
Your response must be concise. 1.52e+1. What is the difference between the highest and the second highest Value added (current US$) of Agriculture?
Ensure brevity in your answer.  2.78e+1. What is the difference between the highest and the lowest Value added (current US$) in Industry?
Offer a terse response. 1.28e+09. What is the difference between the highest and the lowest Value added (current US$) of Manufacturing?
Give a very brief answer. 2.63e+1. What is the difference between the highest and the lowest Value added (current US$) of Services?
Provide a succinct answer. 1.85e+1. What is the difference between the highest and the lowest Value added (current US$) of Agriculture?
Give a very brief answer. 2.95e+1. 